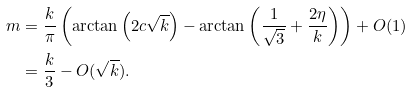<formula> <loc_0><loc_0><loc_500><loc_500>m & = \frac { k } { \pi } \left ( \arctan \left ( 2 c \sqrt { k } \right ) - \arctan \left ( \frac { 1 } { \sqrt { 3 } } + \frac { 2 \eta } { k } \right ) \right ) + O ( 1 ) \\ & = \frac { k } { 3 } - O ( \sqrt { k } ) .</formula> 